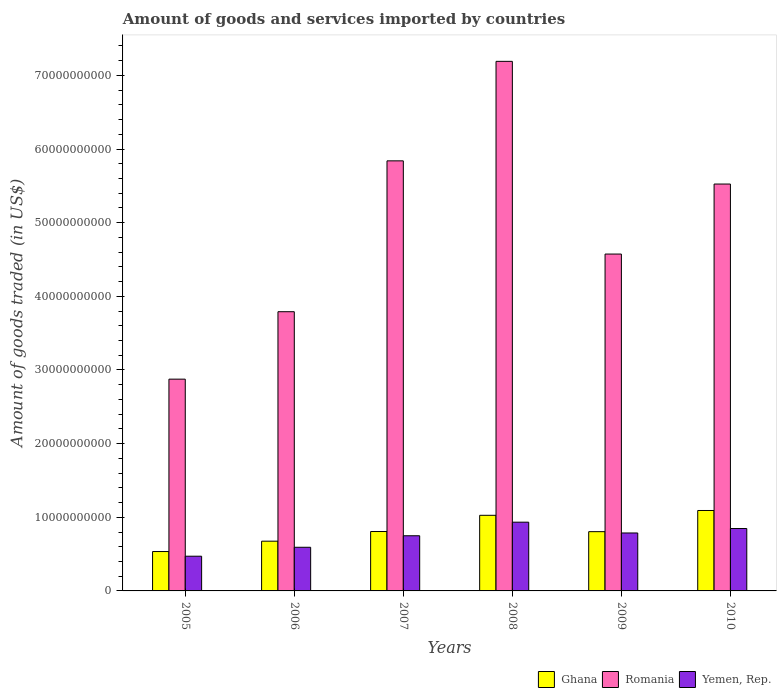How many different coloured bars are there?
Your answer should be very brief. 3. How many groups of bars are there?
Make the answer very short. 6. How many bars are there on the 1st tick from the left?
Your answer should be compact. 3. How many bars are there on the 1st tick from the right?
Your answer should be compact. 3. In how many cases, is the number of bars for a given year not equal to the number of legend labels?
Provide a succinct answer. 0. What is the total amount of goods and services imported in Romania in 2010?
Make the answer very short. 5.53e+1. Across all years, what is the maximum total amount of goods and services imported in Yemen, Rep.?
Keep it short and to the point. 9.33e+09. Across all years, what is the minimum total amount of goods and services imported in Romania?
Give a very brief answer. 2.88e+1. In which year was the total amount of goods and services imported in Yemen, Rep. maximum?
Offer a terse response. 2008. What is the total total amount of goods and services imported in Ghana in the graph?
Ensure brevity in your answer.  4.94e+1. What is the difference between the total amount of goods and services imported in Yemen, Rep. in 2005 and that in 2010?
Your answer should be compact. -3.76e+09. What is the difference between the total amount of goods and services imported in Ghana in 2008 and the total amount of goods and services imported in Yemen, Rep. in 2006?
Give a very brief answer. 4.34e+09. What is the average total amount of goods and services imported in Romania per year?
Keep it short and to the point. 4.97e+1. In the year 2010, what is the difference between the total amount of goods and services imported in Ghana and total amount of goods and services imported in Yemen, Rep.?
Ensure brevity in your answer.  2.45e+09. What is the ratio of the total amount of goods and services imported in Ghana in 2009 to that in 2010?
Keep it short and to the point. 0.74. Is the total amount of goods and services imported in Yemen, Rep. in 2006 less than that in 2010?
Your answer should be very brief. Yes. Is the difference between the total amount of goods and services imported in Ghana in 2006 and 2007 greater than the difference between the total amount of goods and services imported in Yemen, Rep. in 2006 and 2007?
Offer a very short reply. Yes. What is the difference between the highest and the second highest total amount of goods and services imported in Romania?
Keep it short and to the point. 1.35e+1. What is the difference between the highest and the lowest total amount of goods and services imported in Yemen, Rep.?
Your answer should be compact. 4.62e+09. In how many years, is the total amount of goods and services imported in Yemen, Rep. greater than the average total amount of goods and services imported in Yemen, Rep. taken over all years?
Provide a short and direct response. 4. Is the sum of the total amount of goods and services imported in Yemen, Rep. in 2005 and 2007 greater than the maximum total amount of goods and services imported in Ghana across all years?
Offer a terse response. Yes. What does the 2nd bar from the left in 2009 represents?
Keep it short and to the point. Romania. What does the 3rd bar from the right in 2005 represents?
Offer a very short reply. Ghana. Is it the case that in every year, the sum of the total amount of goods and services imported in Yemen, Rep. and total amount of goods and services imported in Ghana is greater than the total amount of goods and services imported in Romania?
Your answer should be very brief. No. How many bars are there?
Your response must be concise. 18. Are the values on the major ticks of Y-axis written in scientific E-notation?
Provide a succinct answer. No. Does the graph contain any zero values?
Offer a terse response. No. How are the legend labels stacked?
Offer a terse response. Horizontal. What is the title of the graph?
Provide a short and direct response. Amount of goods and services imported by countries. What is the label or title of the X-axis?
Ensure brevity in your answer.  Years. What is the label or title of the Y-axis?
Keep it short and to the point. Amount of goods traded (in US$). What is the Amount of goods traded (in US$) of Ghana in 2005?
Provide a short and direct response. 5.35e+09. What is the Amount of goods traded (in US$) in Romania in 2005?
Provide a short and direct response. 2.88e+1. What is the Amount of goods traded (in US$) of Yemen, Rep. in 2005?
Offer a very short reply. 4.71e+09. What is the Amount of goods traded (in US$) in Ghana in 2006?
Your response must be concise. 6.75e+09. What is the Amount of goods traded (in US$) in Romania in 2006?
Give a very brief answer. 3.79e+1. What is the Amount of goods traded (in US$) of Yemen, Rep. in 2006?
Your response must be concise. 5.93e+09. What is the Amount of goods traded (in US$) of Ghana in 2007?
Your answer should be very brief. 8.07e+09. What is the Amount of goods traded (in US$) of Romania in 2007?
Offer a terse response. 5.84e+1. What is the Amount of goods traded (in US$) in Yemen, Rep. in 2007?
Keep it short and to the point. 7.49e+09. What is the Amount of goods traded (in US$) of Ghana in 2008?
Ensure brevity in your answer.  1.03e+1. What is the Amount of goods traded (in US$) in Romania in 2008?
Keep it short and to the point. 7.19e+1. What is the Amount of goods traded (in US$) in Yemen, Rep. in 2008?
Provide a short and direct response. 9.33e+09. What is the Amount of goods traded (in US$) of Ghana in 2009?
Keep it short and to the point. 8.05e+09. What is the Amount of goods traded (in US$) in Romania in 2009?
Offer a terse response. 4.57e+1. What is the Amount of goods traded (in US$) of Yemen, Rep. in 2009?
Make the answer very short. 7.87e+09. What is the Amount of goods traded (in US$) in Ghana in 2010?
Offer a very short reply. 1.09e+1. What is the Amount of goods traded (in US$) in Romania in 2010?
Provide a succinct answer. 5.53e+1. What is the Amount of goods traded (in US$) of Yemen, Rep. in 2010?
Make the answer very short. 8.47e+09. Across all years, what is the maximum Amount of goods traded (in US$) in Ghana?
Provide a short and direct response. 1.09e+1. Across all years, what is the maximum Amount of goods traded (in US$) in Romania?
Offer a very short reply. 7.19e+1. Across all years, what is the maximum Amount of goods traded (in US$) in Yemen, Rep.?
Your answer should be very brief. 9.33e+09. Across all years, what is the minimum Amount of goods traded (in US$) of Ghana?
Offer a very short reply. 5.35e+09. Across all years, what is the minimum Amount of goods traded (in US$) of Romania?
Offer a very short reply. 2.88e+1. Across all years, what is the minimum Amount of goods traded (in US$) in Yemen, Rep.?
Your answer should be very brief. 4.71e+09. What is the total Amount of goods traded (in US$) in Ghana in the graph?
Provide a short and direct response. 4.94e+1. What is the total Amount of goods traded (in US$) in Romania in the graph?
Your answer should be compact. 2.98e+11. What is the total Amount of goods traded (in US$) in Yemen, Rep. in the graph?
Offer a terse response. 4.38e+1. What is the difference between the Amount of goods traded (in US$) in Ghana in 2005 and that in 2006?
Offer a very short reply. -1.41e+09. What is the difference between the Amount of goods traded (in US$) of Romania in 2005 and that in 2006?
Offer a terse response. -9.16e+09. What is the difference between the Amount of goods traded (in US$) of Yemen, Rep. in 2005 and that in 2006?
Your answer should be compact. -1.21e+09. What is the difference between the Amount of goods traded (in US$) in Ghana in 2005 and that in 2007?
Offer a terse response. -2.72e+09. What is the difference between the Amount of goods traded (in US$) in Romania in 2005 and that in 2007?
Provide a short and direct response. -2.96e+1. What is the difference between the Amount of goods traded (in US$) in Yemen, Rep. in 2005 and that in 2007?
Make the answer very short. -2.78e+09. What is the difference between the Amount of goods traded (in US$) in Ghana in 2005 and that in 2008?
Offer a very short reply. -4.92e+09. What is the difference between the Amount of goods traded (in US$) of Romania in 2005 and that in 2008?
Your response must be concise. -4.32e+1. What is the difference between the Amount of goods traded (in US$) in Yemen, Rep. in 2005 and that in 2008?
Ensure brevity in your answer.  -4.62e+09. What is the difference between the Amount of goods traded (in US$) of Ghana in 2005 and that in 2009?
Offer a very short reply. -2.70e+09. What is the difference between the Amount of goods traded (in US$) of Romania in 2005 and that in 2009?
Make the answer very short. -1.70e+1. What is the difference between the Amount of goods traded (in US$) in Yemen, Rep. in 2005 and that in 2009?
Provide a short and direct response. -3.15e+09. What is the difference between the Amount of goods traded (in US$) in Ghana in 2005 and that in 2010?
Make the answer very short. -5.57e+09. What is the difference between the Amount of goods traded (in US$) of Romania in 2005 and that in 2010?
Offer a terse response. -2.65e+1. What is the difference between the Amount of goods traded (in US$) in Yemen, Rep. in 2005 and that in 2010?
Your answer should be compact. -3.76e+09. What is the difference between the Amount of goods traded (in US$) of Ghana in 2006 and that in 2007?
Keep it short and to the point. -1.31e+09. What is the difference between the Amount of goods traded (in US$) of Romania in 2006 and that in 2007?
Provide a short and direct response. -2.05e+1. What is the difference between the Amount of goods traded (in US$) in Yemen, Rep. in 2006 and that in 2007?
Keep it short and to the point. -1.56e+09. What is the difference between the Amount of goods traded (in US$) in Ghana in 2006 and that in 2008?
Provide a succinct answer. -3.51e+09. What is the difference between the Amount of goods traded (in US$) of Romania in 2006 and that in 2008?
Provide a succinct answer. -3.40e+1. What is the difference between the Amount of goods traded (in US$) of Yemen, Rep. in 2006 and that in 2008?
Make the answer very short. -3.41e+09. What is the difference between the Amount of goods traded (in US$) of Ghana in 2006 and that in 2009?
Provide a succinct answer. -1.29e+09. What is the difference between the Amount of goods traded (in US$) in Romania in 2006 and that in 2009?
Offer a very short reply. -7.83e+09. What is the difference between the Amount of goods traded (in US$) in Yemen, Rep. in 2006 and that in 2009?
Provide a short and direct response. -1.94e+09. What is the difference between the Amount of goods traded (in US$) in Ghana in 2006 and that in 2010?
Give a very brief answer. -4.17e+09. What is the difference between the Amount of goods traded (in US$) in Romania in 2006 and that in 2010?
Make the answer very short. -1.73e+1. What is the difference between the Amount of goods traded (in US$) of Yemen, Rep. in 2006 and that in 2010?
Give a very brief answer. -2.55e+09. What is the difference between the Amount of goods traded (in US$) of Ghana in 2007 and that in 2008?
Offer a very short reply. -2.20e+09. What is the difference between the Amount of goods traded (in US$) in Romania in 2007 and that in 2008?
Give a very brief answer. -1.35e+1. What is the difference between the Amount of goods traded (in US$) in Yemen, Rep. in 2007 and that in 2008?
Your answer should be compact. -1.84e+09. What is the difference between the Amount of goods traded (in US$) of Ghana in 2007 and that in 2009?
Provide a short and direct response. 1.99e+07. What is the difference between the Amount of goods traded (in US$) in Romania in 2007 and that in 2009?
Ensure brevity in your answer.  1.27e+1. What is the difference between the Amount of goods traded (in US$) of Yemen, Rep. in 2007 and that in 2009?
Your answer should be very brief. -3.78e+08. What is the difference between the Amount of goods traded (in US$) in Ghana in 2007 and that in 2010?
Provide a short and direct response. -2.86e+09. What is the difference between the Amount of goods traded (in US$) of Romania in 2007 and that in 2010?
Your answer should be very brief. 3.15e+09. What is the difference between the Amount of goods traded (in US$) in Yemen, Rep. in 2007 and that in 2010?
Provide a short and direct response. -9.83e+08. What is the difference between the Amount of goods traded (in US$) in Ghana in 2008 and that in 2009?
Your response must be concise. 2.22e+09. What is the difference between the Amount of goods traded (in US$) in Romania in 2008 and that in 2009?
Make the answer very short. 2.62e+1. What is the difference between the Amount of goods traded (in US$) in Yemen, Rep. in 2008 and that in 2009?
Offer a terse response. 1.47e+09. What is the difference between the Amount of goods traded (in US$) of Ghana in 2008 and that in 2010?
Your answer should be compact. -6.54e+08. What is the difference between the Amount of goods traded (in US$) of Romania in 2008 and that in 2010?
Keep it short and to the point. 1.67e+1. What is the difference between the Amount of goods traded (in US$) of Yemen, Rep. in 2008 and that in 2010?
Make the answer very short. 8.61e+08. What is the difference between the Amount of goods traded (in US$) in Ghana in 2009 and that in 2010?
Your answer should be very brief. -2.88e+09. What is the difference between the Amount of goods traded (in US$) in Romania in 2009 and that in 2010?
Make the answer very short. -9.51e+09. What is the difference between the Amount of goods traded (in US$) in Yemen, Rep. in 2009 and that in 2010?
Offer a terse response. -6.05e+08. What is the difference between the Amount of goods traded (in US$) in Ghana in 2005 and the Amount of goods traded (in US$) in Romania in 2006?
Provide a succinct answer. -3.26e+1. What is the difference between the Amount of goods traded (in US$) in Ghana in 2005 and the Amount of goods traded (in US$) in Yemen, Rep. in 2006?
Keep it short and to the point. -5.79e+08. What is the difference between the Amount of goods traded (in US$) of Romania in 2005 and the Amount of goods traded (in US$) of Yemen, Rep. in 2006?
Provide a short and direct response. 2.28e+1. What is the difference between the Amount of goods traded (in US$) in Ghana in 2005 and the Amount of goods traded (in US$) in Romania in 2007?
Provide a short and direct response. -5.31e+1. What is the difference between the Amount of goods traded (in US$) of Ghana in 2005 and the Amount of goods traded (in US$) of Yemen, Rep. in 2007?
Provide a succinct answer. -2.14e+09. What is the difference between the Amount of goods traded (in US$) of Romania in 2005 and the Amount of goods traded (in US$) of Yemen, Rep. in 2007?
Give a very brief answer. 2.13e+1. What is the difference between the Amount of goods traded (in US$) of Ghana in 2005 and the Amount of goods traded (in US$) of Romania in 2008?
Provide a succinct answer. -6.66e+1. What is the difference between the Amount of goods traded (in US$) of Ghana in 2005 and the Amount of goods traded (in US$) of Yemen, Rep. in 2008?
Keep it short and to the point. -3.99e+09. What is the difference between the Amount of goods traded (in US$) in Romania in 2005 and the Amount of goods traded (in US$) in Yemen, Rep. in 2008?
Your response must be concise. 1.94e+1. What is the difference between the Amount of goods traded (in US$) of Ghana in 2005 and the Amount of goods traded (in US$) of Romania in 2009?
Your response must be concise. -4.04e+1. What is the difference between the Amount of goods traded (in US$) of Ghana in 2005 and the Amount of goods traded (in US$) of Yemen, Rep. in 2009?
Offer a terse response. -2.52e+09. What is the difference between the Amount of goods traded (in US$) in Romania in 2005 and the Amount of goods traded (in US$) in Yemen, Rep. in 2009?
Your answer should be compact. 2.09e+1. What is the difference between the Amount of goods traded (in US$) of Ghana in 2005 and the Amount of goods traded (in US$) of Romania in 2010?
Ensure brevity in your answer.  -4.99e+1. What is the difference between the Amount of goods traded (in US$) in Ghana in 2005 and the Amount of goods traded (in US$) in Yemen, Rep. in 2010?
Your answer should be compact. -3.13e+09. What is the difference between the Amount of goods traded (in US$) in Romania in 2005 and the Amount of goods traded (in US$) in Yemen, Rep. in 2010?
Offer a terse response. 2.03e+1. What is the difference between the Amount of goods traded (in US$) of Ghana in 2006 and the Amount of goods traded (in US$) of Romania in 2007?
Offer a very short reply. -5.16e+1. What is the difference between the Amount of goods traded (in US$) of Ghana in 2006 and the Amount of goods traded (in US$) of Yemen, Rep. in 2007?
Provide a short and direct response. -7.37e+08. What is the difference between the Amount of goods traded (in US$) of Romania in 2006 and the Amount of goods traded (in US$) of Yemen, Rep. in 2007?
Give a very brief answer. 3.04e+1. What is the difference between the Amount of goods traded (in US$) of Ghana in 2006 and the Amount of goods traded (in US$) of Romania in 2008?
Offer a terse response. -6.52e+1. What is the difference between the Amount of goods traded (in US$) in Ghana in 2006 and the Amount of goods traded (in US$) in Yemen, Rep. in 2008?
Your answer should be very brief. -2.58e+09. What is the difference between the Amount of goods traded (in US$) in Romania in 2006 and the Amount of goods traded (in US$) in Yemen, Rep. in 2008?
Give a very brief answer. 2.86e+1. What is the difference between the Amount of goods traded (in US$) in Ghana in 2006 and the Amount of goods traded (in US$) in Romania in 2009?
Make the answer very short. -3.90e+1. What is the difference between the Amount of goods traded (in US$) of Ghana in 2006 and the Amount of goods traded (in US$) of Yemen, Rep. in 2009?
Provide a succinct answer. -1.11e+09. What is the difference between the Amount of goods traded (in US$) of Romania in 2006 and the Amount of goods traded (in US$) of Yemen, Rep. in 2009?
Give a very brief answer. 3.00e+1. What is the difference between the Amount of goods traded (in US$) of Ghana in 2006 and the Amount of goods traded (in US$) of Romania in 2010?
Offer a terse response. -4.85e+1. What is the difference between the Amount of goods traded (in US$) of Ghana in 2006 and the Amount of goods traded (in US$) of Yemen, Rep. in 2010?
Your response must be concise. -1.72e+09. What is the difference between the Amount of goods traded (in US$) in Romania in 2006 and the Amount of goods traded (in US$) in Yemen, Rep. in 2010?
Your response must be concise. 2.94e+1. What is the difference between the Amount of goods traded (in US$) in Ghana in 2007 and the Amount of goods traded (in US$) in Romania in 2008?
Keep it short and to the point. -6.38e+1. What is the difference between the Amount of goods traded (in US$) in Ghana in 2007 and the Amount of goods traded (in US$) in Yemen, Rep. in 2008?
Offer a terse response. -1.27e+09. What is the difference between the Amount of goods traded (in US$) in Romania in 2007 and the Amount of goods traded (in US$) in Yemen, Rep. in 2008?
Offer a very short reply. 4.91e+1. What is the difference between the Amount of goods traded (in US$) in Ghana in 2007 and the Amount of goods traded (in US$) in Romania in 2009?
Make the answer very short. -3.77e+1. What is the difference between the Amount of goods traded (in US$) in Ghana in 2007 and the Amount of goods traded (in US$) in Yemen, Rep. in 2009?
Make the answer very short. 1.98e+08. What is the difference between the Amount of goods traded (in US$) of Romania in 2007 and the Amount of goods traded (in US$) of Yemen, Rep. in 2009?
Give a very brief answer. 5.05e+1. What is the difference between the Amount of goods traded (in US$) of Ghana in 2007 and the Amount of goods traded (in US$) of Romania in 2010?
Provide a succinct answer. -4.72e+1. What is the difference between the Amount of goods traded (in US$) of Ghana in 2007 and the Amount of goods traded (in US$) of Yemen, Rep. in 2010?
Give a very brief answer. -4.07e+08. What is the difference between the Amount of goods traded (in US$) of Romania in 2007 and the Amount of goods traded (in US$) of Yemen, Rep. in 2010?
Provide a succinct answer. 4.99e+1. What is the difference between the Amount of goods traded (in US$) of Ghana in 2008 and the Amount of goods traded (in US$) of Romania in 2009?
Keep it short and to the point. -3.55e+1. What is the difference between the Amount of goods traded (in US$) in Ghana in 2008 and the Amount of goods traded (in US$) in Yemen, Rep. in 2009?
Your response must be concise. 2.40e+09. What is the difference between the Amount of goods traded (in US$) of Romania in 2008 and the Amount of goods traded (in US$) of Yemen, Rep. in 2009?
Keep it short and to the point. 6.40e+1. What is the difference between the Amount of goods traded (in US$) of Ghana in 2008 and the Amount of goods traded (in US$) of Romania in 2010?
Provide a succinct answer. -4.50e+1. What is the difference between the Amount of goods traded (in US$) in Ghana in 2008 and the Amount of goods traded (in US$) in Yemen, Rep. in 2010?
Ensure brevity in your answer.  1.80e+09. What is the difference between the Amount of goods traded (in US$) in Romania in 2008 and the Amount of goods traded (in US$) in Yemen, Rep. in 2010?
Provide a short and direct response. 6.34e+1. What is the difference between the Amount of goods traded (in US$) in Ghana in 2009 and the Amount of goods traded (in US$) in Romania in 2010?
Ensure brevity in your answer.  -4.72e+1. What is the difference between the Amount of goods traded (in US$) of Ghana in 2009 and the Amount of goods traded (in US$) of Yemen, Rep. in 2010?
Give a very brief answer. -4.27e+08. What is the difference between the Amount of goods traded (in US$) in Romania in 2009 and the Amount of goods traded (in US$) in Yemen, Rep. in 2010?
Offer a very short reply. 3.73e+1. What is the average Amount of goods traded (in US$) in Ghana per year?
Provide a short and direct response. 8.23e+09. What is the average Amount of goods traded (in US$) of Romania per year?
Ensure brevity in your answer.  4.97e+1. What is the average Amount of goods traded (in US$) in Yemen, Rep. per year?
Your response must be concise. 7.30e+09. In the year 2005, what is the difference between the Amount of goods traded (in US$) in Ghana and Amount of goods traded (in US$) in Romania?
Offer a terse response. -2.34e+1. In the year 2005, what is the difference between the Amount of goods traded (in US$) of Ghana and Amount of goods traded (in US$) of Yemen, Rep.?
Your answer should be very brief. 6.34e+08. In the year 2005, what is the difference between the Amount of goods traded (in US$) in Romania and Amount of goods traded (in US$) in Yemen, Rep.?
Ensure brevity in your answer.  2.40e+1. In the year 2006, what is the difference between the Amount of goods traded (in US$) of Ghana and Amount of goods traded (in US$) of Romania?
Your answer should be compact. -3.12e+1. In the year 2006, what is the difference between the Amount of goods traded (in US$) in Ghana and Amount of goods traded (in US$) in Yemen, Rep.?
Give a very brief answer. 8.28e+08. In the year 2006, what is the difference between the Amount of goods traded (in US$) in Romania and Amount of goods traded (in US$) in Yemen, Rep.?
Keep it short and to the point. 3.20e+1. In the year 2007, what is the difference between the Amount of goods traded (in US$) of Ghana and Amount of goods traded (in US$) of Romania?
Provide a short and direct response. -5.03e+1. In the year 2007, what is the difference between the Amount of goods traded (in US$) of Ghana and Amount of goods traded (in US$) of Yemen, Rep.?
Make the answer very short. 5.76e+08. In the year 2007, what is the difference between the Amount of goods traded (in US$) of Romania and Amount of goods traded (in US$) of Yemen, Rep.?
Keep it short and to the point. 5.09e+1. In the year 2008, what is the difference between the Amount of goods traded (in US$) in Ghana and Amount of goods traded (in US$) in Romania?
Provide a short and direct response. -6.16e+1. In the year 2008, what is the difference between the Amount of goods traded (in US$) of Ghana and Amount of goods traded (in US$) of Yemen, Rep.?
Ensure brevity in your answer.  9.35e+08. In the year 2008, what is the difference between the Amount of goods traded (in US$) in Romania and Amount of goods traded (in US$) in Yemen, Rep.?
Provide a short and direct response. 6.26e+1. In the year 2009, what is the difference between the Amount of goods traded (in US$) in Ghana and Amount of goods traded (in US$) in Romania?
Your answer should be very brief. -3.77e+1. In the year 2009, what is the difference between the Amount of goods traded (in US$) in Ghana and Amount of goods traded (in US$) in Yemen, Rep.?
Provide a short and direct response. 1.78e+08. In the year 2009, what is the difference between the Amount of goods traded (in US$) of Romania and Amount of goods traded (in US$) of Yemen, Rep.?
Provide a succinct answer. 3.79e+1. In the year 2010, what is the difference between the Amount of goods traded (in US$) in Ghana and Amount of goods traded (in US$) in Romania?
Provide a succinct answer. -4.43e+1. In the year 2010, what is the difference between the Amount of goods traded (in US$) in Ghana and Amount of goods traded (in US$) in Yemen, Rep.?
Offer a terse response. 2.45e+09. In the year 2010, what is the difference between the Amount of goods traded (in US$) of Romania and Amount of goods traded (in US$) of Yemen, Rep.?
Your response must be concise. 4.68e+1. What is the ratio of the Amount of goods traded (in US$) in Ghana in 2005 to that in 2006?
Your answer should be very brief. 0.79. What is the ratio of the Amount of goods traded (in US$) in Romania in 2005 to that in 2006?
Your response must be concise. 0.76. What is the ratio of the Amount of goods traded (in US$) of Yemen, Rep. in 2005 to that in 2006?
Offer a terse response. 0.8. What is the ratio of the Amount of goods traded (in US$) in Ghana in 2005 to that in 2007?
Offer a very short reply. 0.66. What is the ratio of the Amount of goods traded (in US$) of Romania in 2005 to that in 2007?
Keep it short and to the point. 0.49. What is the ratio of the Amount of goods traded (in US$) in Yemen, Rep. in 2005 to that in 2007?
Provide a short and direct response. 0.63. What is the ratio of the Amount of goods traded (in US$) of Ghana in 2005 to that in 2008?
Your response must be concise. 0.52. What is the ratio of the Amount of goods traded (in US$) of Romania in 2005 to that in 2008?
Provide a short and direct response. 0.4. What is the ratio of the Amount of goods traded (in US$) of Yemen, Rep. in 2005 to that in 2008?
Offer a very short reply. 0.5. What is the ratio of the Amount of goods traded (in US$) of Ghana in 2005 to that in 2009?
Offer a very short reply. 0.66. What is the ratio of the Amount of goods traded (in US$) in Romania in 2005 to that in 2009?
Give a very brief answer. 0.63. What is the ratio of the Amount of goods traded (in US$) of Yemen, Rep. in 2005 to that in 2009?
Offer a terse response. 0.6. What is the ratio of the Amount of goods traded (in US$) in Ghana in 2005 to that in 2010?
Provide a succinct answer. 0.49. What is the ratio of the Amount of goods traded (in US$) in Romania in 2005 to that in 2010?
Offer a very short reply. 0.52. What is the ratio of the Amount of goods traded (in US$) in Yemen, Rep. in 2005 to that in 2010?
Make the answer very short. 0.56. What is the ratio of the Amount of goods traded (in US$) of Ghana in 2006 to that in 2007?
Offer a very short reply. 0.84. What is the ratio of the Amount of goods traded (in US$) of Romania in 2006 to that in 2007?
Keep it short and to the point. 0.65. What is the ratio of the Amount of goods traded (in US$) in Yemen, Rep. in 2006 to that in 2007?
Provide a succinct answer. 0.79. What is the ratio of the Amount of goods traded (in US$) in Ghana in 2006 to that in 2008?
Your response must be concise. 0.66. What is the ratio of the Amount of goods traded (in US$) in Romania in 2006 to that in 2008?
Keep it short and to the point. 0.53. What is the ratio of the Amount of goods traded (in US$) in Yemen, Rep. in 2006 to that in 2008?
Keep it short and to the point. 0.63. What is the ratio of the Amount of goods traded (in US$) of Ghana in 2006 to that in 2009?
Your answer should be very brief. 0.84. What is the ratio of the Amount of goods traded (in US$) in Romania in 2006 to that in 2009?
Give a very brief answer. 0.83. What is the ratio of the Amount of goods traded (in US$) in Yemen, Rep. in 2006 to that in 2009?
Make the answer very short. 0.75. What is the ratio of the Amount of goods traded (in US$) of Ghana in 2006 to that in 2010?
Give a very brief answer. 0.62. What is the ratio of the Amount of goods traded (in US$) in Romania in 2006 to that in 2010?
Offer a terse response. 0.69. What is the ratio of the Amount of goods traded (in US$) in Yemen, Rep. in 2006 to that in 2010?
Keep it short and to the point. 0.7. What is the ratio of the Amount of goods traded (in US$) of Ghana in 2007 to that in 2008?
Provide a succinct answer. 0.79. What is the ratio of the Amount of goods traded (in US$) in Romania in 2007 to that in 2008?
Provide a short and direct response. 0.81. What is the ratio of the Amount of goods traded (in US$) of Yemen, Rep. in 2007 to that in 2008?
Provide a succinct answer. 0.8. What is the ratio of the Amount of goods traded (in US$) of Ghana in 2007 to that in 2009?
Ensure brevity in your answer.  1. What is the ratio of the Amount of goods traded (in US$) of Romania in 2007 to that in 2009?
Your answer should be compact. 1.28. What is the ratio of the Amount of goods traded (in US$) of Ghana in 2007 to that in 2010?
Keep it short and to the point. 0.74. What is the ratio of the Amount of goods traded (in US$) of Romania in 2007 to that in 2010?
Give a very brief answer. 1.06. What is the ratio of the Amount of goods traded (in US$) of Yemen, Rep. in 2007 to that in 2010?
Your answer should be very brief. 0.88. What is the ratio of the Amount of goods traded (in US$) of Ghana in 2008 to that in 2009?
Provide a succinct answer. 1.28. What is the ratio of the Amount of goods traded (in US$) of Romania in 2008 to that in 2009?
Give a very brief answer. 1.57. What is the ratio of the Amount of goods traded (in US$) in Yemen, Rep. in 2008 to that in 2009?
Offer a terse response. 1.19. What is the ratio of the Amount of goods traded (in US$) in Ghana in 2008 to that in 2010?
Offer a terse response. 0.94. What is the ratio of the Amount of goods traded (in US$) in Romania in 2008 to that in 2010?
Keep it short and to the point. 1.3. What is the ratio of the Amount of goods traded (in US$) of Yemen, Rep. in 2008 to that in 2010?
Ensure brevity in your answer.  1.1. What is the ratio of the Amount of goods traded (in US$) in Ghana in 2009 to that in 2010?
Your response must be concise. 0.74. What is the ratio of the Amount of goods traded (in US$) in Romania in 2009 to that in 2010?
Ensure brevity in your answer.  0.83. What is the ratio of the Amount of goods traded (in US$) of Yemen, Rep. in 2009 to that in 2010?
Your answer should be very brief. 0.93. What is the difference between the highest and the second highest Amount of goods traded (in US$) in Ghana?
Provide a succinct answer. 6.54e+08. What is the difference between the highest and the second highest Amount of goods traded (in US$) of Romania?
Your answer should be very brief. 1.35e+1. What is the difference between the highest and the second highest Amount of goods traded (in US$) of Yemen, Rep.?
Make the answer very short. 8.61e+08. What is the difference between the highest and the lowest Amount of goods traded (in US$) in Ghana?
Your response must be concise. 5.57e+09. What is the difference between the highest and the lowest Amount of goods traded (in US$) in Romania?
Offer a very short reply. 4.32e+1. What is the difference between the highest and the lowest Amount of goods traded (in US$) of Yemen, Rep.?
Provide a succinct answer. 4.62e+09. 